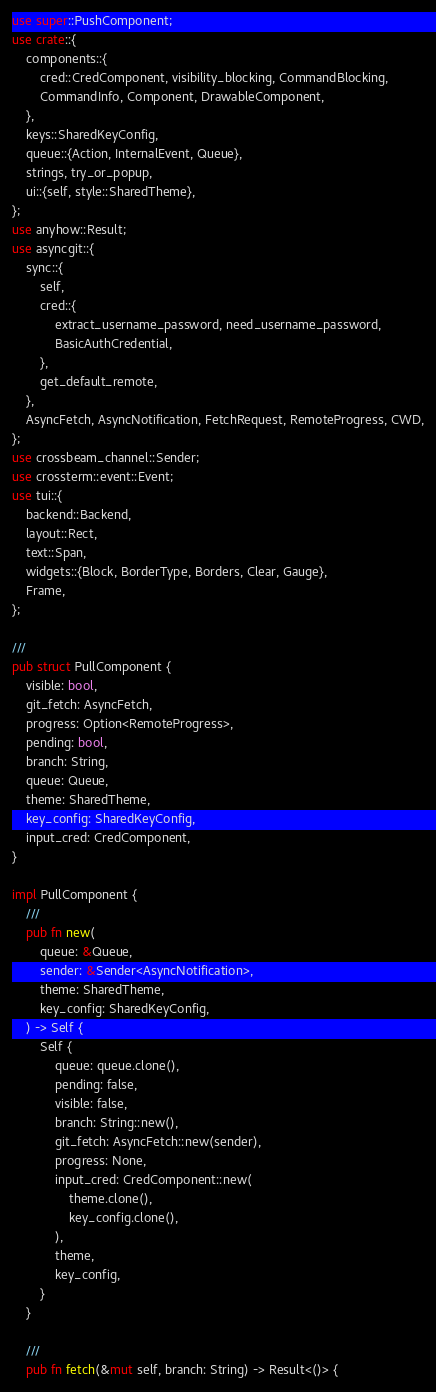<code> <loc_0><loc_0><loc_500><loc_500><_Rust_>use super::PushComponent;
use crate::{
    components::{
        cred::CredComponent, visibility_blocking, CommandBlocking,
        CommandInfo, Component, DrawableComponent,
    },
    keys::SharedKeyConfig,
    queue::{Action, InternalEvent, Queue},
    strings, try_or_popup,
    ui::{self, style::SharedTheme},
};
use anyhow::Result;
use asyncgit::{
    sync::{
        self,
        cred::{
            extract_username_password, need_username_password,
            BasicAuthCredential,
        },
        get_default_remote,
    },
    AsyncFetch, AsyncNotification, FetchRequest, RemoteProgress, CWD,
};
use crossbeam_channel::Sender;
use crossterm::event::Event;
use tui::{
    backend::Backend,
    layout::Rect,
    text::Span,
    widgets::{Block, BorderType, Borders, Clear, Gauge},
    Frame,
};

///
pub struct PullComponent {
    visible: bool,
    git_fetch: AsyncFetch,
    progress: Option<RemoteProgress>,
    pending: bool,
    branch: String,
    queue: Queue,
    theme: SharedTheme,
    key_config: SharedKeyConfig,
    input_cred: CredComponent,
}

impl PullComponent {
    ///
    pub fn new(
        queue: &Queue,
        sender: &Sender<AsyncNotification>,
        theme: SharedTheme,
        key_config: SharedKeyConfig,
    ) -> Self {
        Self {
            queue: queue.clone(),
            pending: false,
            visible: false,
            branch: String::new(),
            git_fetch: AsyncFetch::new(sender),
            progress: None,
            input_cred: CredComponent::new(
                theme.clone(),
                key_config.clone(),
            ),
            theme,
            key_config,
        }
    }

    ///
    pub fn fetch(&mut self, branch: String) -> Result<()> {</code> 